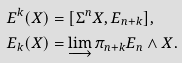<formula> <loc_0><loc_0><loc_500><loc_500>E ^ { k } ( X ) & = [ \Sigma ^ { n } X , E _ { n + k } ] , \\ E _ { k } ( X ) & = \varinjlim \pi _ { n + k } E _ { n } \wedge X .</formula> 